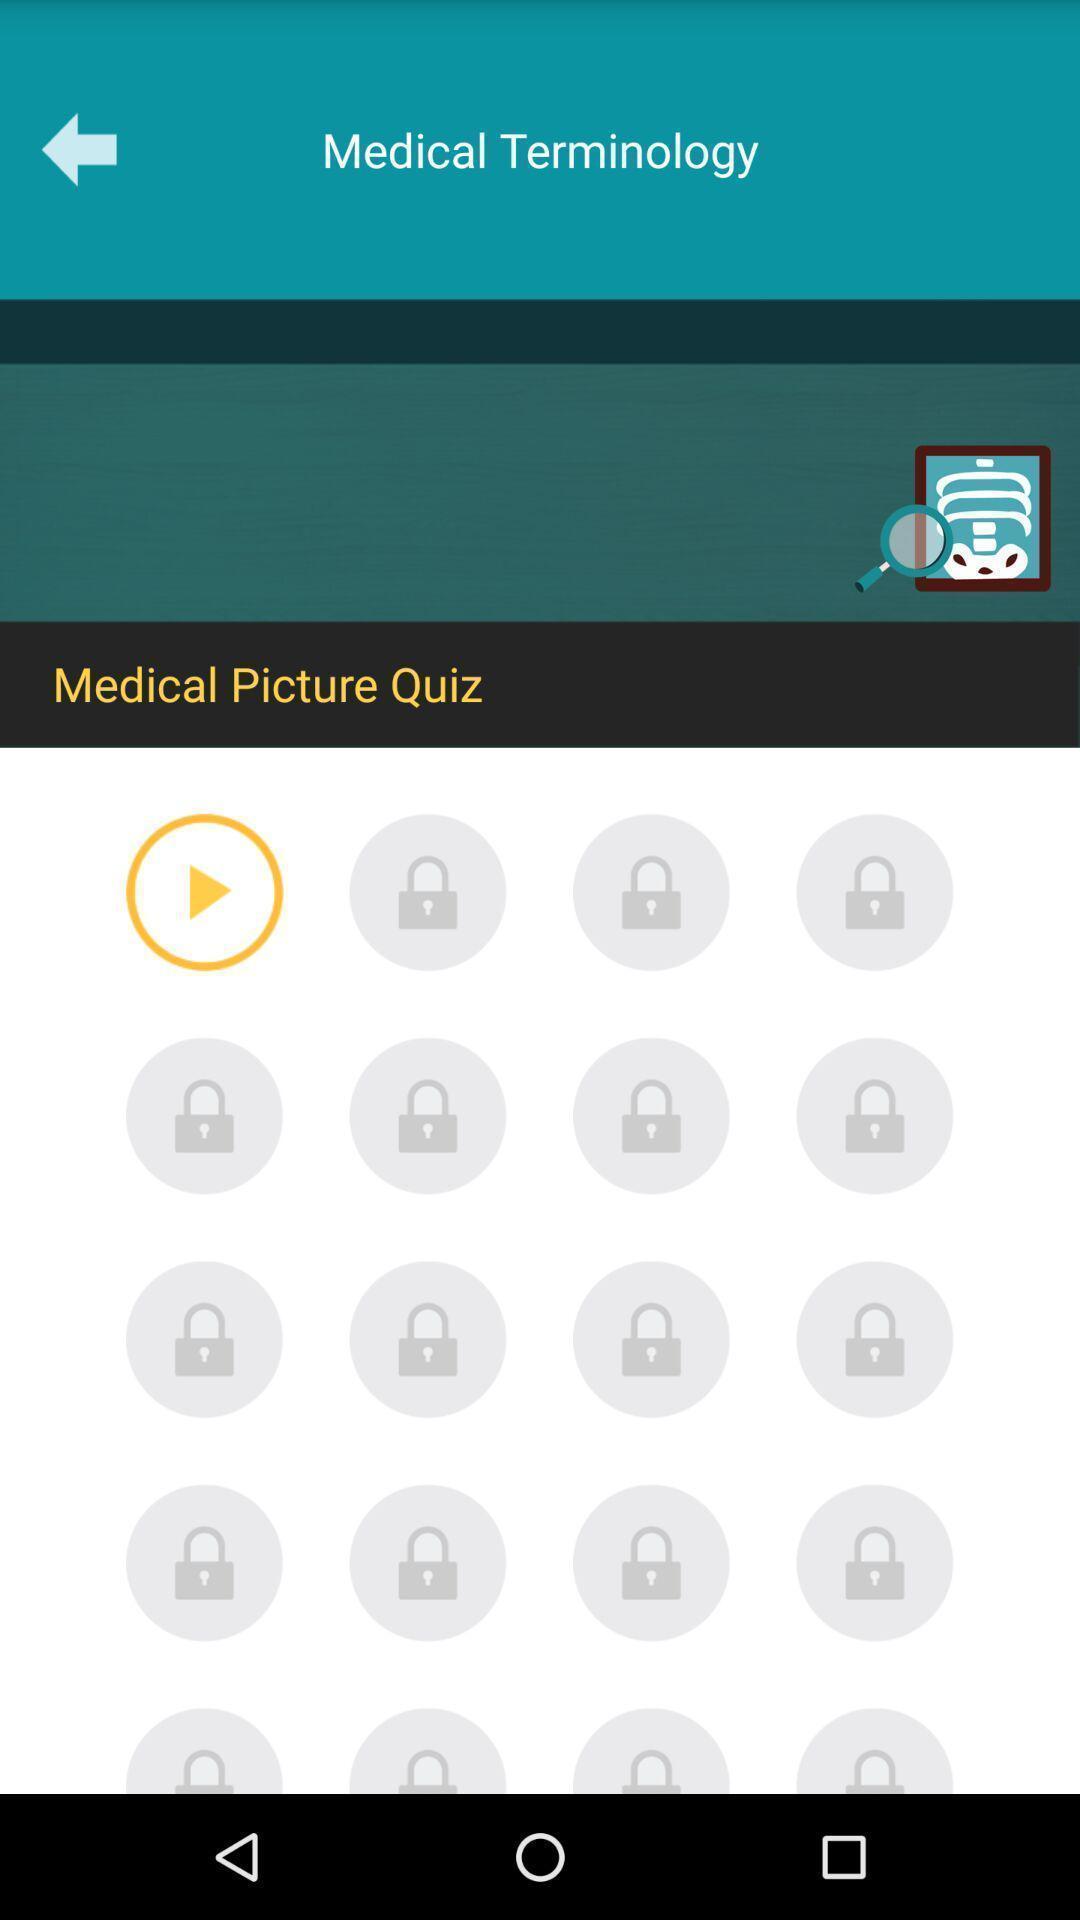Give me a summary of this screen capture. Screen showing medical picture quiz. 